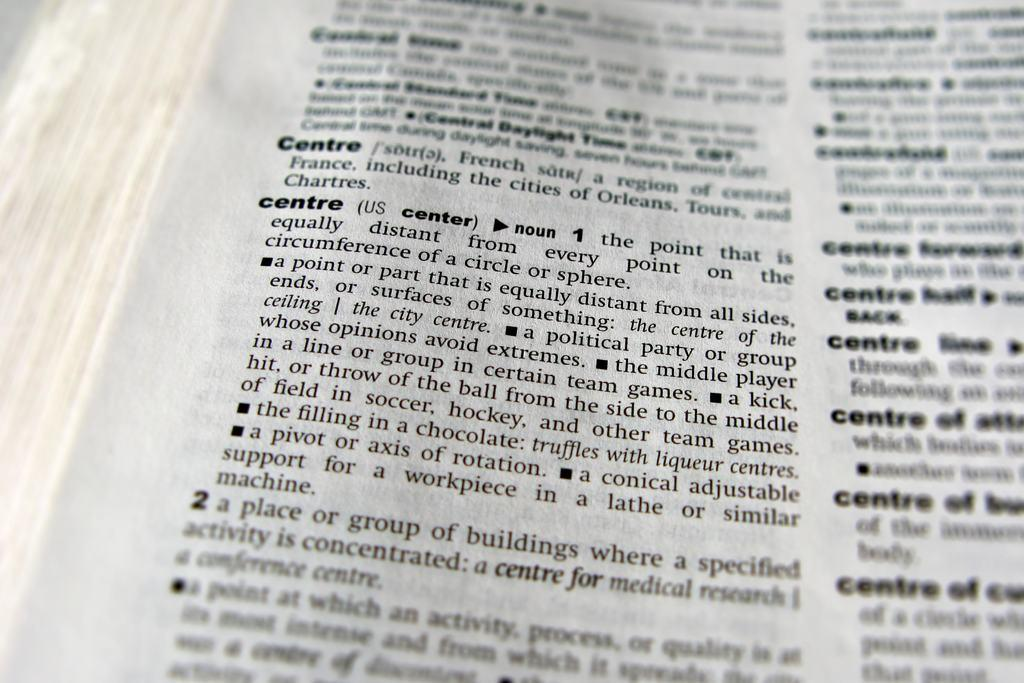Provide a one-sentence caption for the provided image. A close up view of a dictionary page with the definition of the word "centre" showing. 